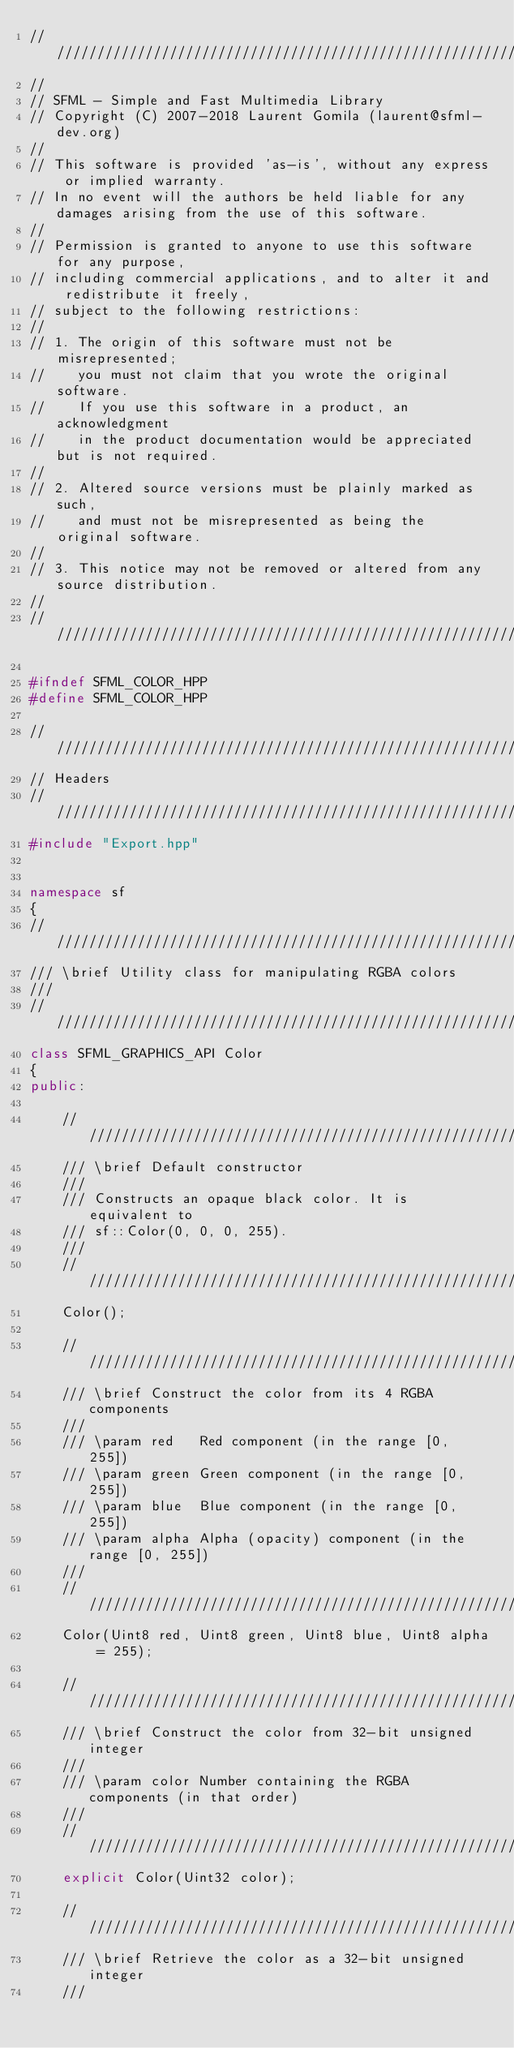Convert code to text. <code><loc_0><loc_0><loc_500><loc_500><_C++_>////////////////////////////////////////////////////////////
//
// SFML - Simple and Fast Multimedia Library
// Copyright (C) 2007-2018 Laurent Gomila (laurent@sfml-dev.org)
//
// This software is provided 'as-is', without any express or implied warranty.
// In no event will the authors be held liable for any damages arising from the use of this software.
//
// Permission is granted to anyone to use this software for any purpose,
// including commercial applications, and to alter it and redistribute it freely,
// subject to the following restrictions:
//
// 1. The origin of this software must not be misrepresented;
//    you must not claim that you wrote the original software.
//    If you use this software in a product, an acknowledgment
//    in the product documentation would be appreciated but is not required.
//
// 2. Altered source versions must be plainly marked as such,
//    and must not be misrepresented as being the original software.
//
// 3. This notice may not be removed or altered from any source distribution.
//
////////////////////////////////////////////////////////////

#ifndef SFML_COLOR_HPP
#define SFML_COLOR_HPP

////////////////////////////////////////////////////////////
// Headers
////////////////////////////////////////////////////////////
#include "Export.hpp"


namespace sf
{
////////////////////////////////////////////////////////////
/// \brief Utility class for manipulating RGBA colors
///
////////////////////////////////////////////////////////////
class SFML_GRAPHICS_API Color
{
public:

    ////////////////////////////////////////////////////////////
    /// \brief Default constructor
    ///
    /// Constructs an opaque black color. It is equivalent to
    /// sf::Color(0, 0, 0, 255).
    ///
    ////////////////////////////////////////////////////////////
    Color();

    ////////////////////////////////////////////////////////////
    /// \brief Construct the color from its 4 RGBA components
    ///
    /// \param red   Red component (in the range [0, 255])
    /// \param green Green component (in the range [0, 255])
    /// \param blue  Blue component (in the range [0, 255])
    /// \param alpha Alpha (opacity) component (in the range [0, 255])
    ///
    ////////////////////////////////////////////////////////////
    Color(Uint8 red, Uint8 green, Uint8 blue, Uint8 alpha = 255);

    ////////////////////////////////////////////////////////////
    /// \brief Construct the color from 32-bit unsigned integer
    ///
    /// \param color Number containing the RGBA components (in that order)
    ///
    ////////////////////////////////////////////////////////////
    explicit Color(Uint32 color);

    ////////////////////////////////////////////////////////////
    /// \brief Retrieve the color as a 32-bit unsigned integer
    ///</code> 